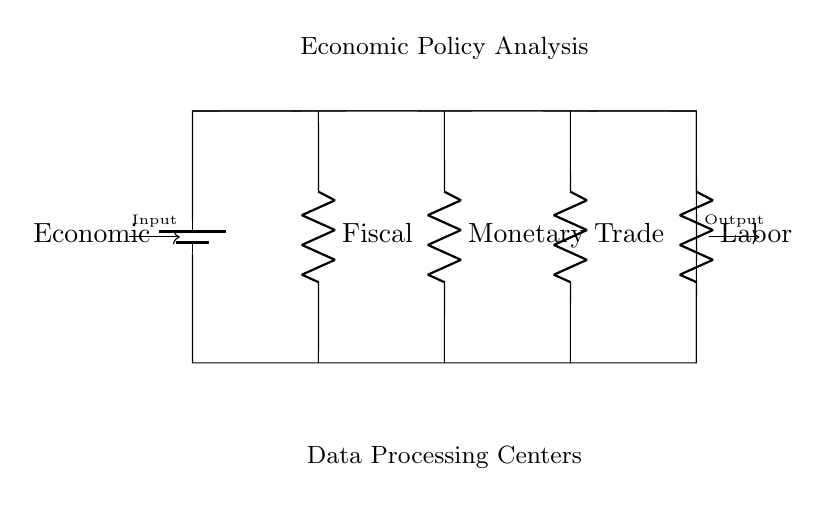What type of circuit is illustrated? The circuit is a parallel circuit, characterized by multiple components connected across the same two points, allowing for multiple pathways for current.
Answer: Parallel How many resistors are in the circuit? There are four resistors in the circuit, representing different fiscal components (Fiscal, Monetary, Trade, and Labor). Count the labeled resistors to confirm this.
Answer: Four What is the primary input to the circuit? The primary input is labeled as "Economic," indicating the source of the voltage or potential for analysis within the economic data processing centers.
Answer: Economic Which component corresponds to fiscal policy? The component corresponding to fiscal policy is labeled "Fiscal," indicating its role in analyzing fiscal measures. Locate the resistor at the leftmost position for confirmation.
Answer: Fiscal What factors are analyzed by the data processing centers? The data processing centers analyze four factors: Fiscal, Monetary, Trade, and Labor, as represented by the four resistors connected in parallel.
Answer: Fiscal, Monetary, Trade, Labor How does the output relate to the input in this circuit? The output reflects the combined analysis of the input economic data processed through the parallel resistors, providing a comprehensive view of economic policies. This relationship indicates the summation of effects from individual components.
Answer: Combined analysis 